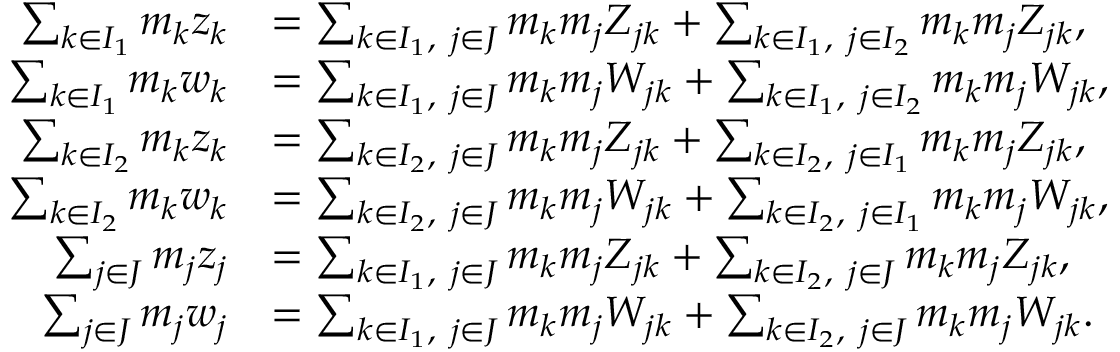<formula> <loc_0><loc_0><loc_500><loc_500>\begin{array} { r l r l r } & { \sum _ { k \in I _ { 1 } } m _ { k } z _ { k } } & { = \sum _ { k \in I _ { 1 } , \ j \in J } m _ { k } m _ { j } Z _ { j k } + \sum _ { k \in I _ { 1 } , \ j \in I _ { 2 } } m _ { k } m _ { j } Z _ { j k } , } & \\ & { \sum _ { k \in I _ { 1 } } m _ { k } w _ { k } } & { = \sum _ { k \in I _ { 1 } , \ j \in J } m _ { k } m _ { j } W _ { j k } + \sum _ { k \in I _ { 1 } , \ j \in I _ { 2 } } m _ { k } m _ { j } W _ { j k } , } & \\ & { \sum _ { k \in I _ { 2 } } m _ { k } z _ { k } } & { = \sum _ { k \in I _ { 2 } , \ j \in J } m _ { k } m _ { j } Z _ { j k } + \sum _ { k \in I _ { 2 } , \ j \in I _ { 1 } } m _ { k } m _ { j } Z _ { j k } , } & \\ & { \sum _ { k \in I _ { 2 } } m _ { k } w _ { k } } & { = \sum _ { k \in I _ { 2 } , \ j \in J } m _ { k } m _ { j } W _ { j k } + \sum _ { k \in I _ { 2 } , \ j \in I _ { 1 } } m _ { k } m _ { j } W _ { j k } , } & \\ & { \sum _ { j \in J } m _ { j } z _ { j } } & { = \sum _ { k \in I _ { 1 } , \ j \in J } m _ { k } m _ { j } Z _ { j k } + \sum _ { k \in I _ { 2 } , \ j \in J } m _ { k } m _ { j } Z _ { j k } , } & \\ & { \sum _ { j \in J } m _ { j } w _ { j } } & { = \sum _ { k \in I _ { 1 } , \ j \in J } m _ { k } m _ { j } W _ { j k } + \sum _ { k \in I _ { 2 } , \ j \in J } m _ { k } m _ { j } W _ { j k } . } & \end{array}</formula> 